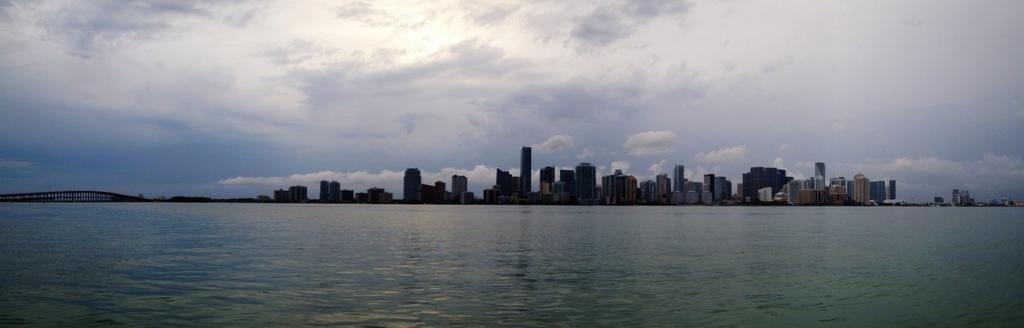What is present at the bottom of the image? There is water at the bottom side of the image. What can be seen in the center of the image? There are buildings in the center of the image. How many ducks are swimming in the water at the bottom of the image? There are no ducks present in the image; it only features water at the bottom side. What type of quilt is covering the buildings in the center of the image? There is no quilt present in the image; it only features buildings in the center. 